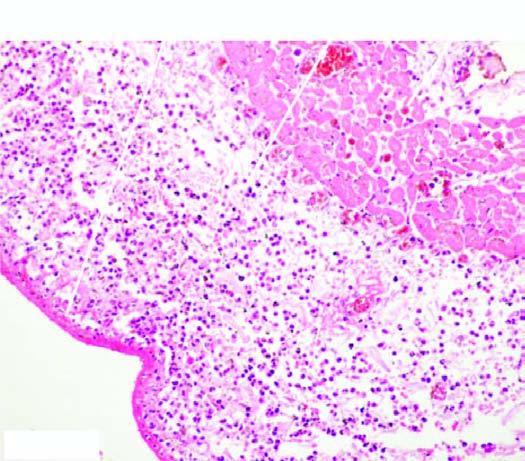what contains numerous inflammatory cells, chiefly pmns?
Answer the question using a single word or phrase. The space between the layers of the pericardium 